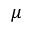Convert formula to latex. <formula><loc_0><loc_0><loc_500><loc_500>\mu</formula> 